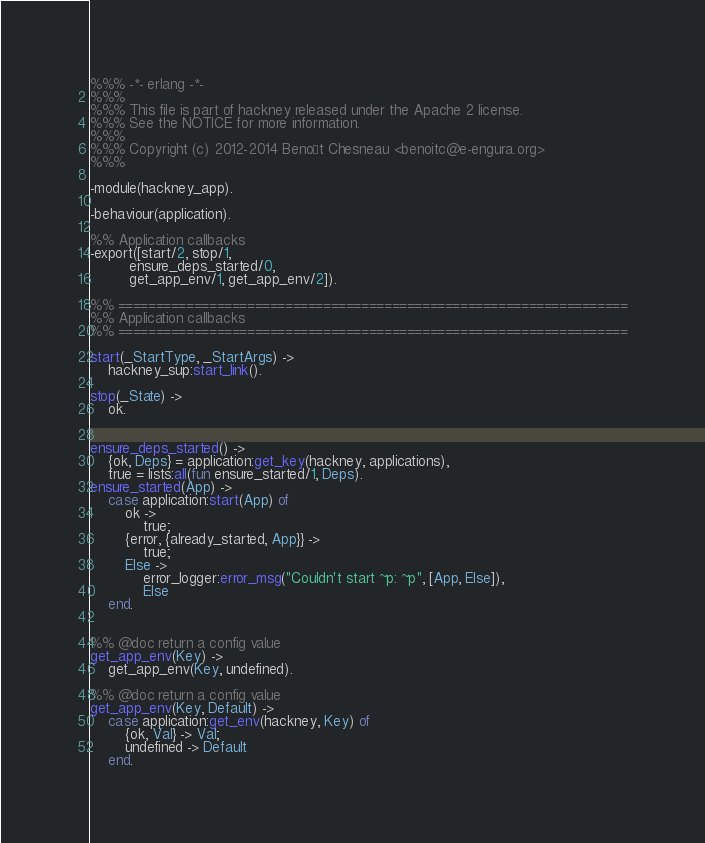<code> <loc_0><loc_0><loc_500><loc_500><_Erlang_>%%% -*- erlang -*-
%%%
%%% This file is part of hackney released under the Apache 2 license.
%%% See the NOTICE for more information.
%%%
%%% Copyright (c) 2012-2014 Benoît Chesneau <benoitc@e-engura.org>
%%%

-module(hackney_app).

-behaviour(application).

%% Application callbacks
-export([start/2, stop/1,
         ensure_deps_started/0,
         get_app_env/1, get_app_env/2]).

%% ===================================================================
%% Application callbacks
%% ===================================================================

start(_StartType, _StartArgs) ->
    hackney_sup:start_link().

stop(_State) ->
    ok.


ensure_deps_started() ->
    {ok, Deps} = application:get_key(hackney, applications),
    true = lists:all(fun ensure_started/1, Deps).
ensure_started(App) ->
    case application:start(App) of
        ok ->
            true;
        {error, {already_started, App}} ->
            true;
        Else ->
            error_logger:error_msg("Couldn't start ~p: ~p", [App, Else]),
            Else
    end.


%% @doc return a config value
get_app_env(Key) ->
    get_app_env(Key, undefined).

%% @doc return a config value
get_app_env(Key, Default) ->
    case application:get_env(hackney, Key) of
        {ok, Val} -> Val;
        undefined -> Default
    end.
</code> 